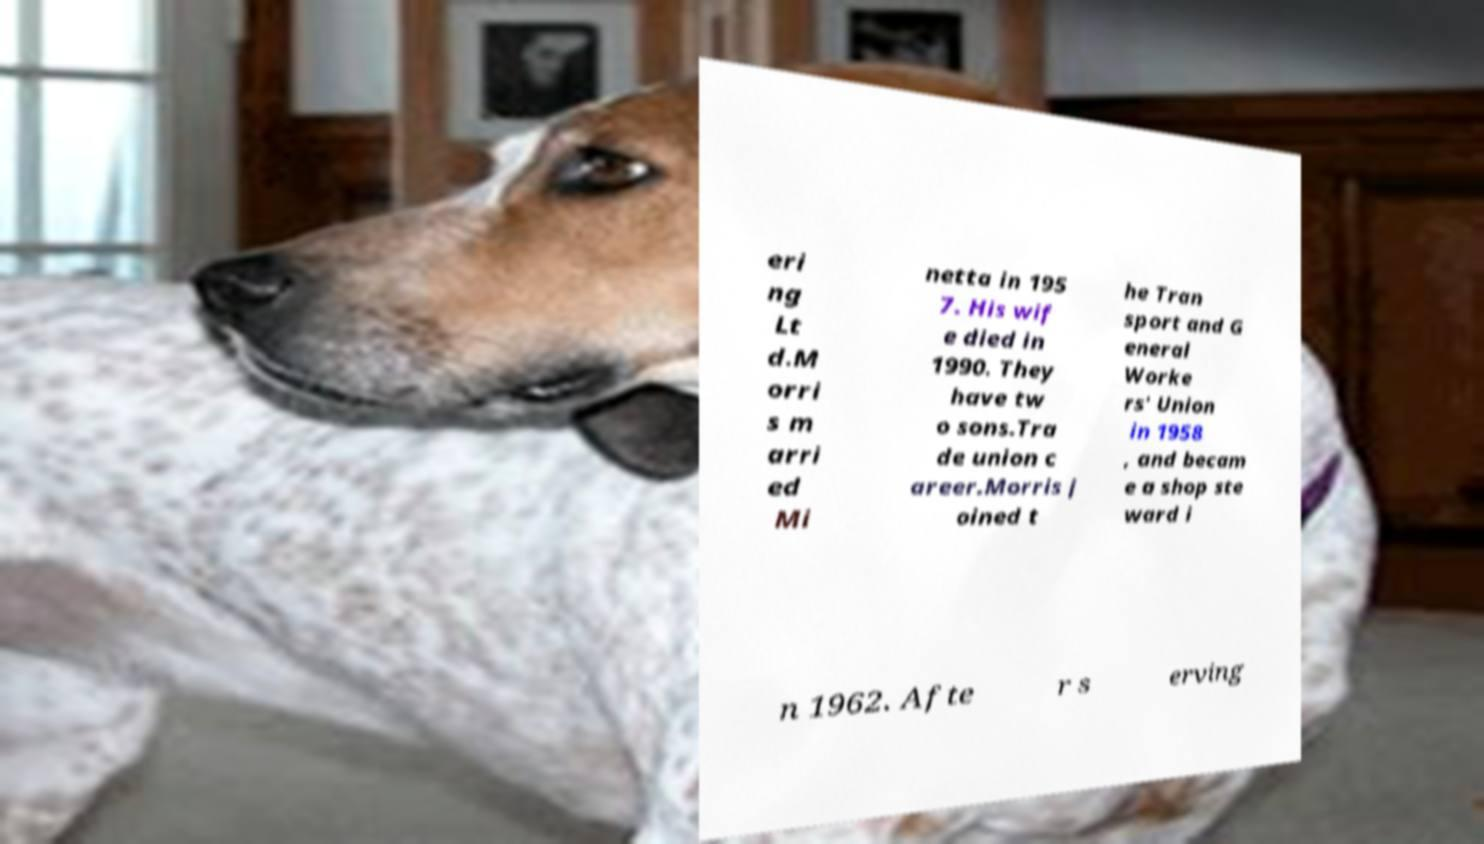Please identify and transcribe the text found in this image. eri ng Lt d.M orri s m arri ed Mi netta in 195 7. His wif e died in 1990. They have tw o sons.Tra de union c areer.Morris j oined t he Tran sport and G eneral Worke rs' Union in 1958 , and becam e a shop ste ward i n 1962. Afte r s erving 